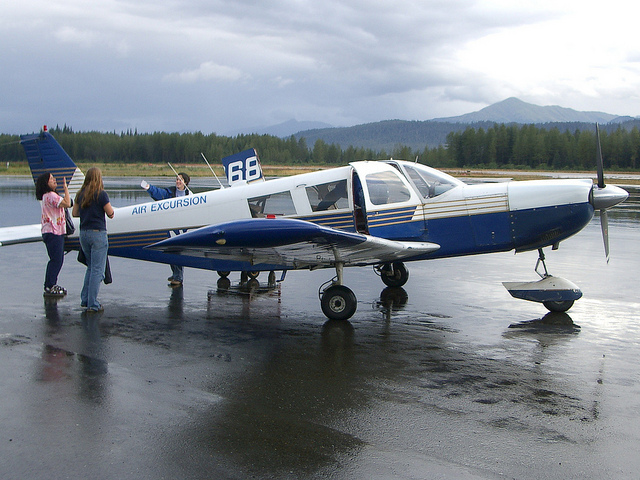Identify the text displayed in this image. 68 AIR EXCURSION 